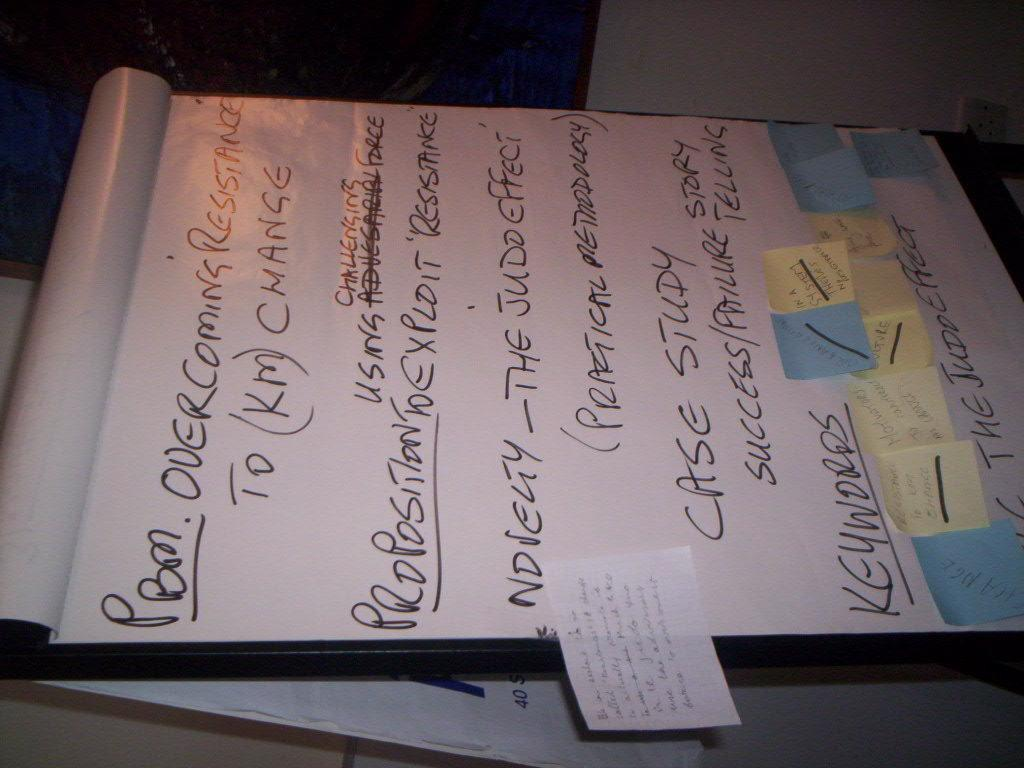<image>
Describe the image concisely. A page is written on in black marker with top line referring to overcoming resistance. 